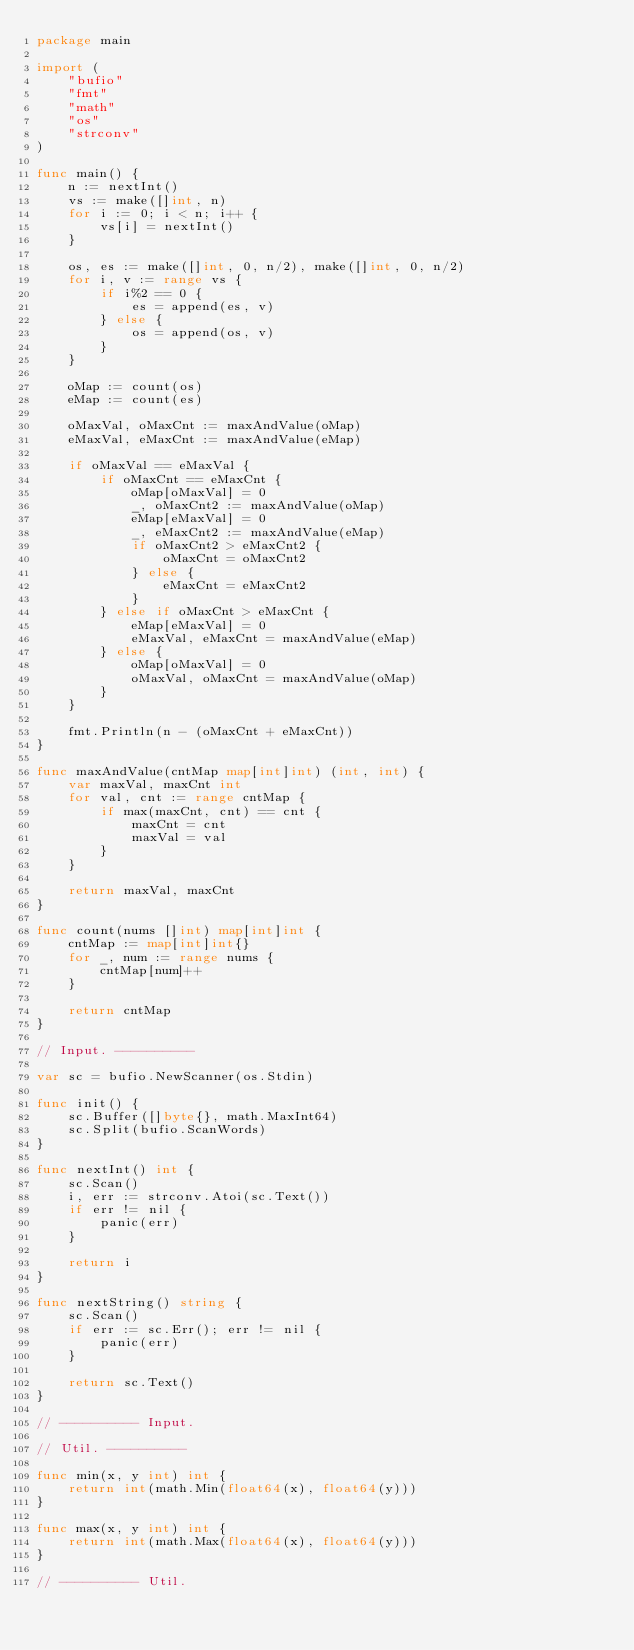Convert code to text. <code><loc_0><loc_0><loc_500><loc_500><_Go_>package main

import (
	"bufio"
	"fmt"
	"math"
	"os"
	"strconv"
)

func main() {
	n := nextInt()
	vs := make([]int, n)
	for i := 0; i < n; i++ {
		vs[i] = nextInt()
	}

	os, es := make([]int, 0, n/2), make([]int, 0, n/2)
	for i, v := range vs {
		if i%2 == 0 {
			es = append(es, v)
		} else {
			os = append(os, v)
		}
	}

	oMap := count(os)
	eMap := count(es)

	oMaxVal, oMaxCnt := maxAndValue(oMap)
	eMaxVal, eMaxCnt := maxAndValue(eMap)

	if oMaxVal == eMaxVal {
		if oMaxCnt == eMaxCnt {
			oMap[oMaxVal] = 0
			_, oMaxCnt2 := maxAndValue(oMap)
			eMap[eMaxVal] = 0
			_, eMaxCnt2 := maxAndValue(eMap)
			if oMaxCnt2 > eMaxCnt2 {
				oMaxCnt = oMaxCnt2
			} else {
				eMaxCnt = eMaxCnt2
			}
		} else if oMaxCnt > eMaxCnt {
			eMap[eMaxVal] = 0
			eMaxVal, eMaxCnt = maxAndValue(eMap)
		} else {
			oMap[oMaxVal] = 0
			oMaxVal, oMaxCnt = maxAndValue(oMap)
		}
	}

	fmt.Println(n - (oMaxCnt + eMaxCnt))
}

func maxAndValue(cntMap map[int]int) (int, int) {
	var maxVal, maxCnt int
	for val, cnt := range cntMap {
		if max(maxCnt, cnt) == cnt {
			maxCnt = cnt
			maxVal = val
		}
	}

	return maxVal, maxCnt
}

func count(nums []int) map[int]int {
	cntMap := map[int]int{}
	for _, num := range nums {
		cntMap[num]++
	}

	return cntMap
}

// Input. ----------

var sc = bufio.NewScanner(os.Stdin)

func init() {
	sc.Buffer([]byte{}, math.MaxInt64)
	sc.Split(bufio.ScanWords)
}

func nextInt() int {
	sc.Scan()
	i, err := strconv.Atoi(sc.Text())
	if err != nil {
		panic(err)
	}

	return i
}

func nextString() string {
	sc.Scan()
	if err := sc.Err(); err != nil {
		panic(err)
	}

	return sc.Text()
}

// ---------- Input.

// Util. ----------

func min(x, y int) int {
	return int(math.Min(float64(x), float64(y)))
}

func max(x, y int) int {
	return int(math.Max(float64(x), float64(y)))
}

// ---------- Util.
</code> 